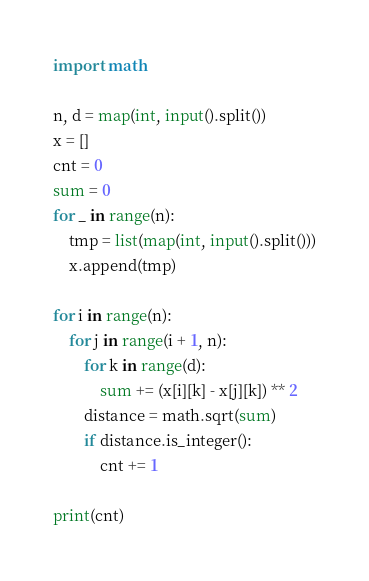Convert code to text. <code><loc_0><loc_0><loc_500><loc_500><_Python_>import math

n, d = map(int, input().split())
x = []
cnt = 0
sum = 0
for _ in range(n):
    tmp = list(map(int, input().split()))
    x.append(tmp)

for i in range(n):
    for j in range(i + 1, n):
        for k in range(d):
            sum += (x[i][k] - x[j][k]) ** 2
        distance = math.sqrt(sum)
        if distance.is_integer():
            cnt += 1

print(cnt)
</code> 